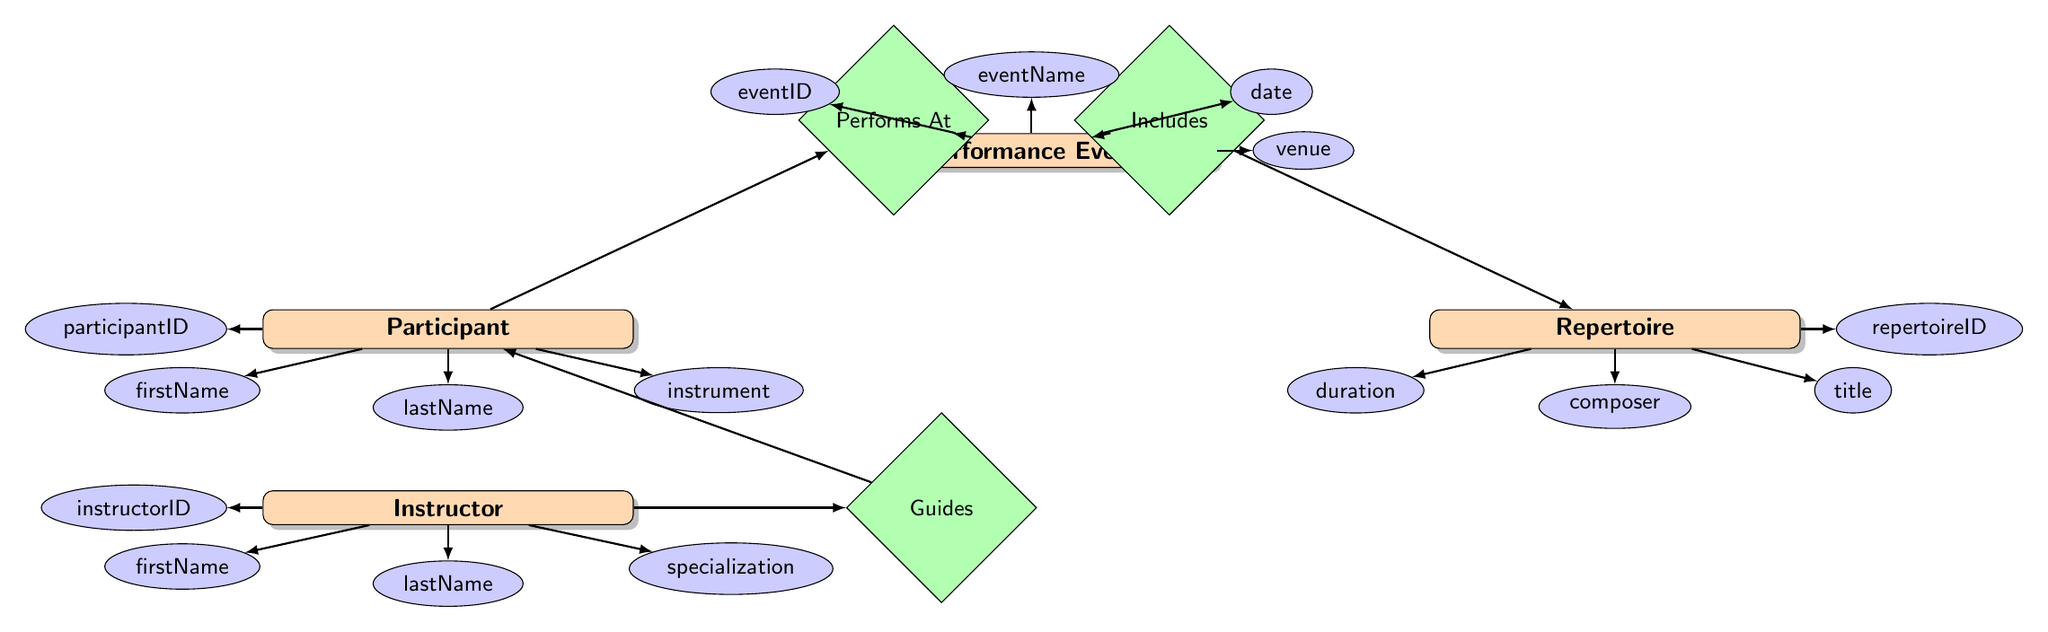What entities are present in the diagram? The diagram includes four entities: Performance Event, Participant, Repertoire, and Instructor. This information can be directly extracted from the labeled entity nodes in the diagram.
Answer: Performance Event, Participant, Repertoire, Instructor How many attributes does the Performance Event have? The Performance Event entity has four attributes: eventID, eventName, date, and venue. This can be counted by looking at the connections to the Performance Event node from the attribute nodes.
Answer: 4 What relationship exists between Participant and Performance Event? The diagram shows a relationship labeled "Performs At" connecting the Participant entity and the Performance Event entity. This relationship can be identified by examining the diamond labeled "Performs At" that lies between the two entities.
Answer: Performs At Which entity guides the Participant? The Instructor entity is connected to the Participant entity through the "Guides" relationship, which shows that the instructor guides the participant during events. This can be identified by following the line from the Instructor entity to the diamond labeled "Guides" that leads to the Participant.
Answer: Instructor What is the relationship that connects Repertoire and Performance Event? The connection between Repertoire and Performance Event is represented by the relationship "Includes," indicating that certain repertoire pieces are included in a performance event. This can be easily identified by the diamond labeled "Includes" between the two entity nodes.
Answer: Includes How many attributes does the Repertoire entity include? The Repertoire entity consists of four attributes: repertoireID, title, composer, and duration. Counting these attributes can be done by looking at the connections from the attribute nodes to the Repertoire entity.
Answer: 4 What is the specialization of the Instructor? The specialization of the Instructor is listed as one of its attributes, but it can vary by individual. Since no specific specialization is referenced in this context, identify the attribute rather than a specific value. This is derived from analyzing the attributes connected to the Instructor entity.
Answer: specialization How many total relationships are depicted in the diagram? The diagram features three relationships: "Performs At," "Includes," and "Guides." By counting the number of diamonds in the relationship section of the diagram, we see there are three distinct relationships present.
Answer: 3 What attribute identifies a Participant? The attribute that identifies a Participant is participantID. This can be established by looking at the attributes connected to the Participant entity and identifying the unique identifier.
Answer: participantID 